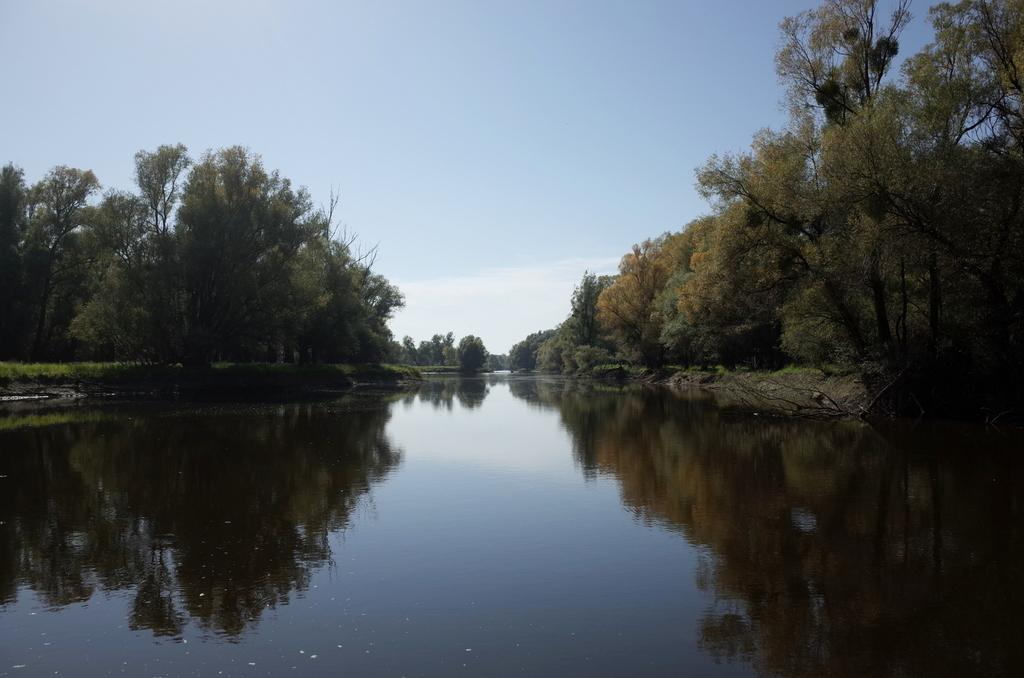What is the primary element visible in the image? There is water in the image. What other natural elements can be seen in the image? There are trees in the image. What is visible in the background of the image? The sky is visible in the background of the image. What can be observed in the sky? Clouds are present in the sky. How many tomatoes are floating on the water in the image? There are no tomatoes present in the image; it only features water, trees, and the sky. What is the distance between the trees and the water in the image? The provided facts do not give information about the distance between the trees and the water, so it cannot be determined from the image. 